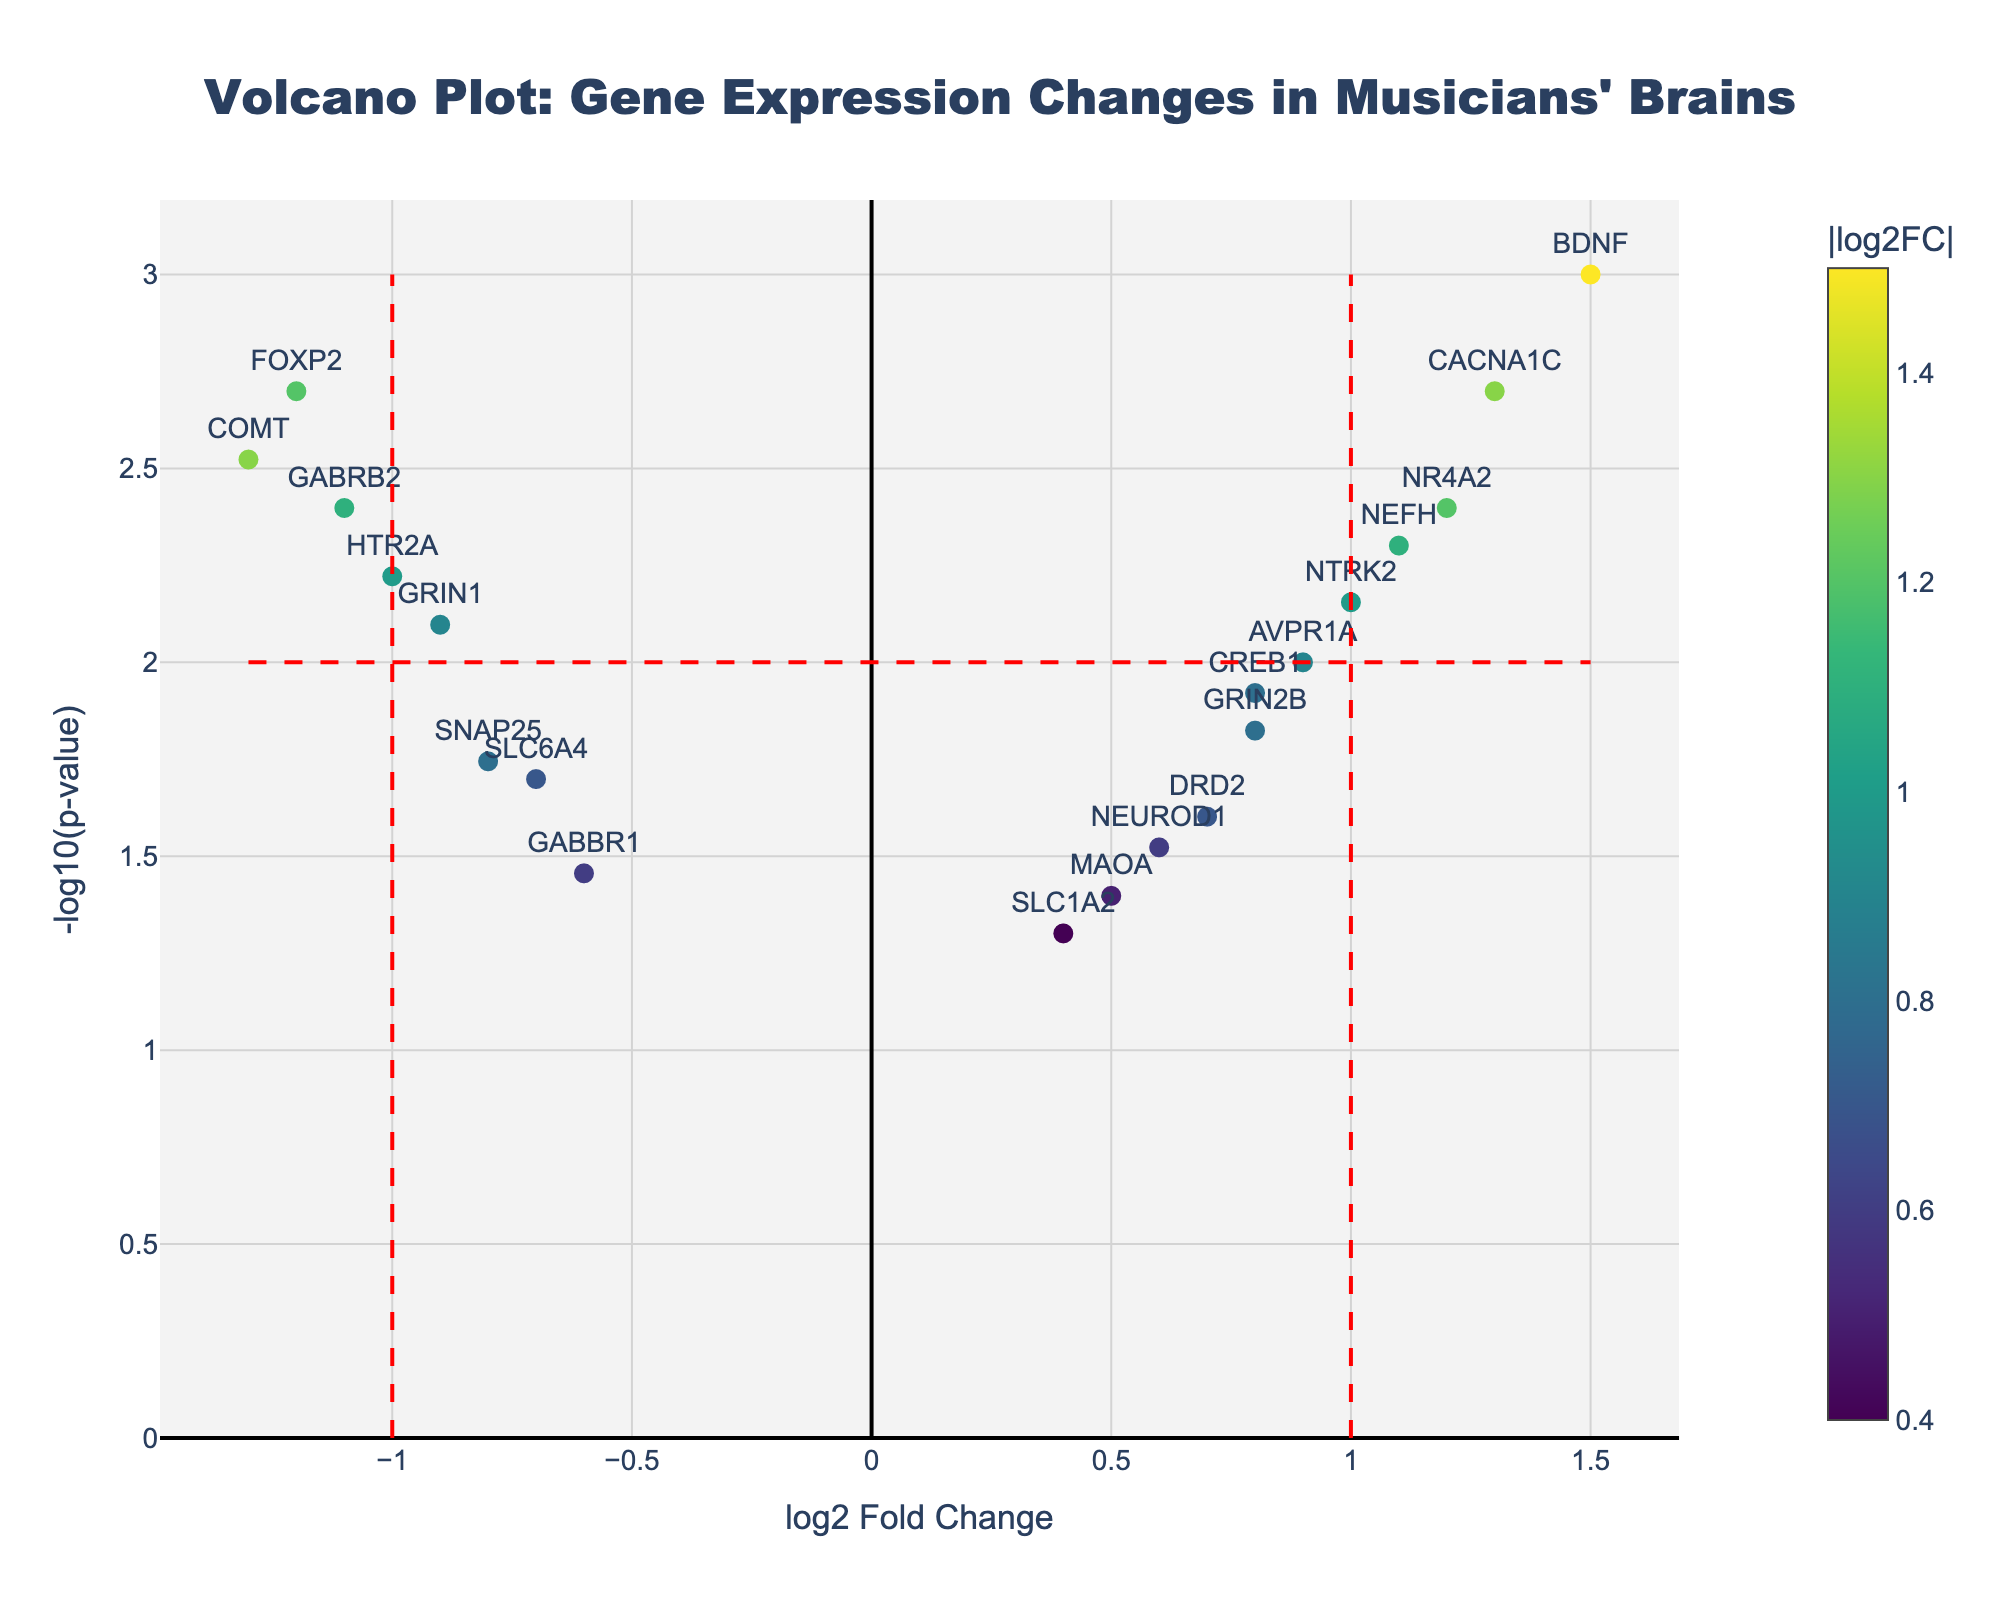Which gene has the highest log2 fold change value? Observe the horizontal axis values to find the highest log2 fold change, which is 1.5 for BDNF.
Answer: BDNF What is the p-value threshold indicated by the horizontal red line? The horizontal red line represents the -log10(p-value) threshold, which corresponds to -log10(0.01) = 2.
Answer: 0.01 How many genes have a log2 fold change greater than 1? Count the points on the right side of the vertical red line at log2 fold change 1. There are 4 genes.
Answer: 4 Which gene shows the most significant decrease in expression (negative log2 fold change) and has a p-value less than 0.01? Look for the most negative log2 fold change value among genes with a -log10(p-value) greater than 2. COMT at -1.3 fits this criterion.
Answer: COMT Among the genes with significant p-values (p < 0.01), which gene has the highest -log10(p-value) value? Find the gene with the highest y-axis value (max -log10(p-value)) among those with p < 0.01. BDNF at -log10(0.001) = 3 has the highest.
Answer: BDNF Compare FOXP2 and GRIN1. Which one has a lower p-value and by how much? Calculate -log10(p-value) for both genes, FOXP2 = -log10(0.002) and GRIN1 = -log10(0.008). FOXP2 has a higher -log10(p-value), meaning it has a lower p-value.
Answer: FOXP2 is lower by 0.006 How many genes have -log10(p-value) values greater than 2? Count the points above the horizontal red line since -log10(p-value) > 2 corresponds to p-value < 0.01. There are 7 genes.
Answer: 7 Which gene has the highest absolute log2 fold change greater than 1 and is upregulated (positive log2 fold change)? Identify genes with log2 fold change greater than 1 and find the one with the highest value. CACNA1C with log2 fold change of 1.3 is the highest.
Answer: CACNA1C What color scale is used for the markers? Observe the color variation of the points in the figure, which follows the 'Viridis' colorscale.
Answer: Viridis 